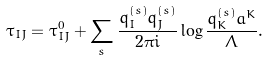<formula> <loc_0><loc_0><loc_500><loc_500>\tau _ { I J } = \tau ^ { 0 } _ { I J } + \sum _ { s } \frac { q ^ { ( s ) } _ { I } q ^ { ( s ) } _ { J } } { 2 \pi i } \log \frac { q ^ { ( s ) } _ { K } a ^ { K } } { \Lambda } .</formula> 